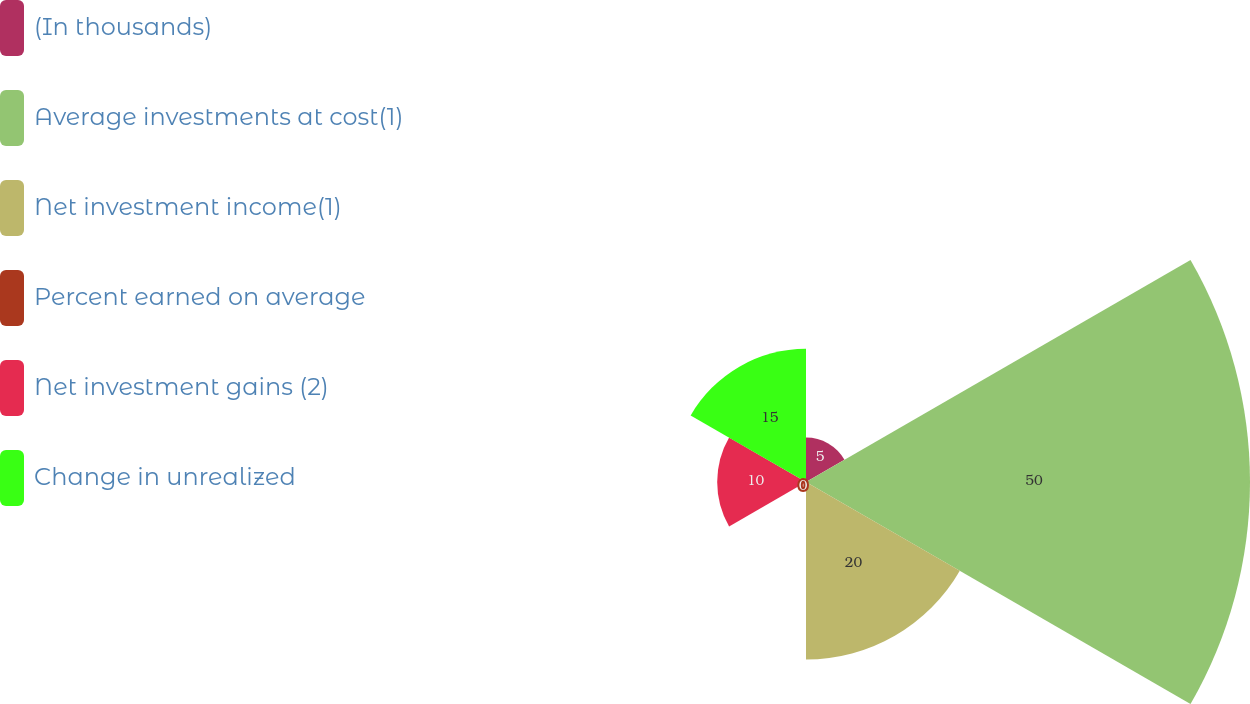Convert chart. <chart><loc_0><loc_0><loc_500><loc_500><pie_chart><fcel>(In thousands)<fcel>Average investments at cost(1)<fcel>Net investment income(1)<fcel>Percent earned on average<fcel>Net investment gains (2)<fcel>Change in unrealized<nl><fcel>5.0%<fcel>50.0%<fcel>20.0%<fcel>0.0%<fcel>10.0%<fcel>15.0%<nl></chart> 